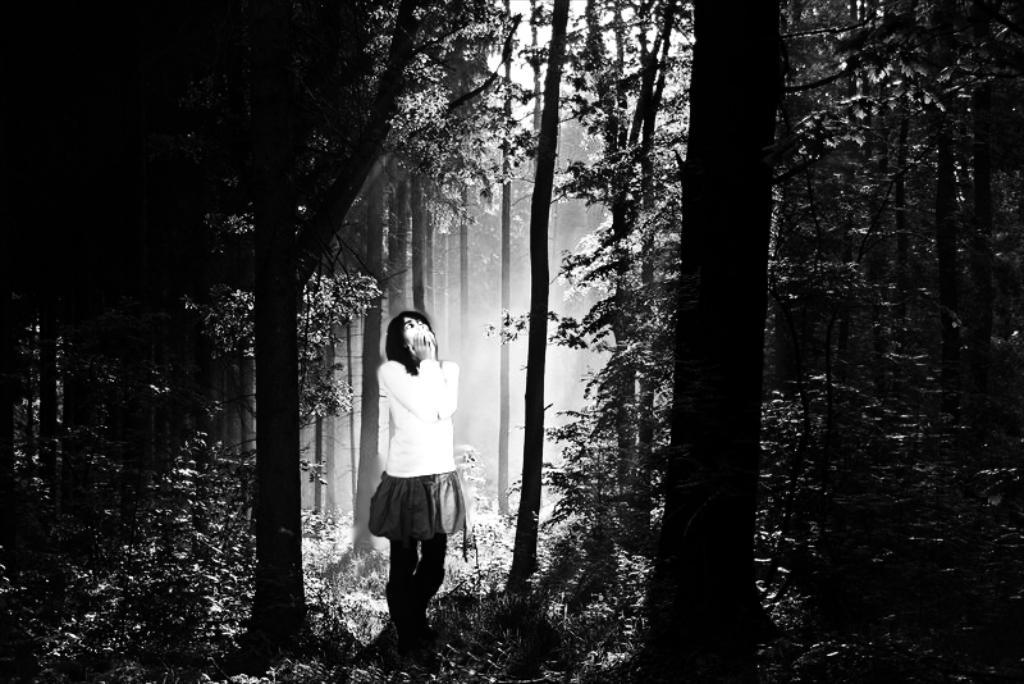Who is in the picture? There is a woman in the picture. What is the woman wearing on her upper body? The woman is wearing a white shirt. What is the woman wearing on her lower body? The woman is wearing a skirt. What type of natural environment surrounds the woman? There are trees and plants around the woman. What type of fuel is being used for the feast in the image? There is no feast or fuel present in the image; it features a woman surrounded by trees and plants. What type of vest is the woman wearing in the image? The woman is not wearing a vest in the image; she is wearing a white shirt and a skirt. 